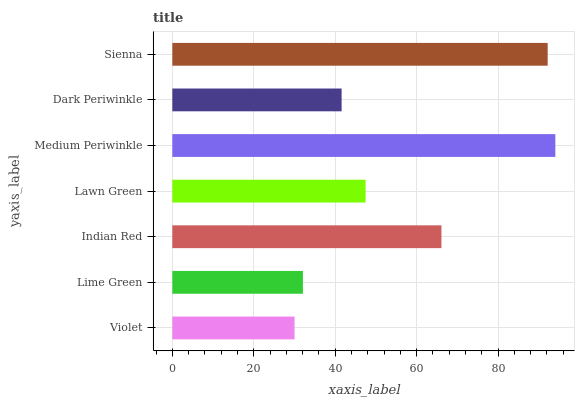Is Violet the minimum?
Answer yes or no. Yes. Is Medium Periwinkle the maximum?
Answer yes or no. Yes. Is Lime Green the minimum?
Answer yes or no. No. Is Lime Green the maximum?
Answer yes or no. No. Is Lime Green greater than Violet?
Answer yes or no. Yes. Is Violet less than Lime Green?
Answer yes or no. Yes. Is Violet greater than Lime Green?
Answer yes or no. No. Is Lime Green less than Violet?
Answer yes or no. No. Is Lawn Green the high median?
Answer yes or no. Yes. Is Lawn Green the low median?
Answer yes or no. Yes. Is Medium Periwinkle the high median?
Answer yes or no. No. Is Lime Green the low median?
Answer yes or no. No. 